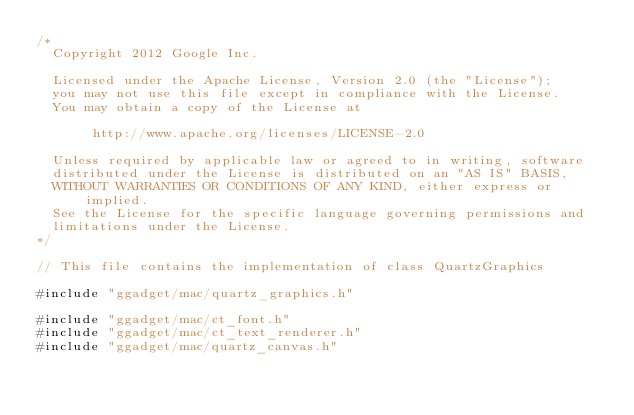Convert code to text. <code><loc_0><loc_0><loc_500><loc_500><_ObjectiveC_>/*
  Copyright 2012 Google Inc.

  Licensed under the Apache License, Version 2.0 (the "License");
  you may not use this file except in compliance with the License.
  You may obtain a copy of the License at

       http://www.apache.org/licenses/LICENSE-2.0

  Unless required by applicable law or agreed to in writing, software
  distributed under the License is distributed on an "AS IS" BASIS,
  WITHOUT WARRANTIES OR CONDITIONS OF ANY KIND, either express or implied.
  See the License for the specific language governing permissions and
  limitations under the License.
*/

// This file contains the implementation of class QuartzGraphics

#include "ggadget/mac/quartz_graphics.h"

#include "ggadget/mac/ct_font.h"
#include "ggadget/mac/ct_text_renderer.h"
#include "ggadget/mac/quartz_canvas.h"</code> 